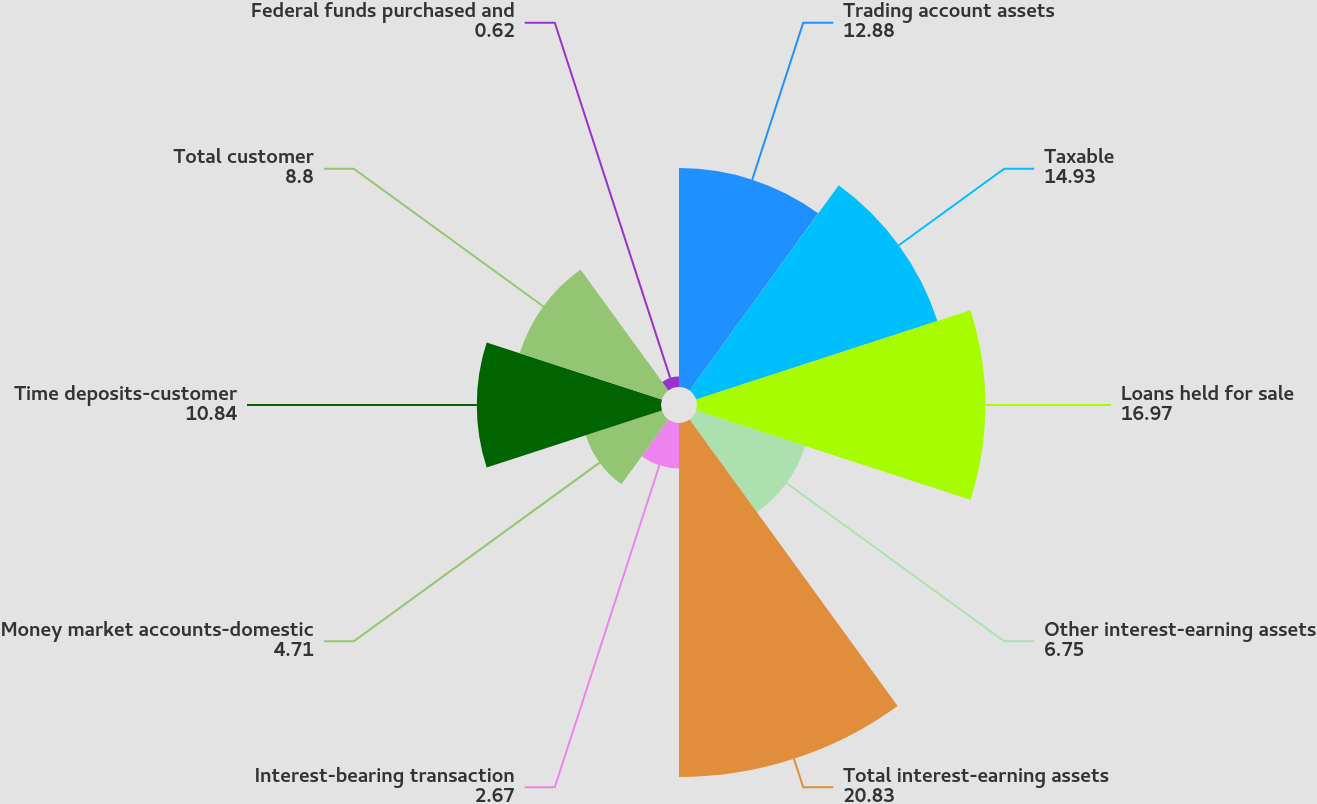<chart> <loc_0><loc_0><loc_500><loc_500><pie_chart><fcel>Trading account assets<fcel>Taxable<fcel>Loans held for sale<fcel>Other interest-earning assets<fcel>Total interest-earning assets<fcel>Interest-bearing transaction<fcel>Money market accounts-domestic<fcel>Time deposits-customer<fcel>Total customer<fcel>Federal funds purchased and<nl><fcel>12.88%<fcel>14.93%<fcel>16.97%<fcel>6.75%<fcel>20.83%<fcel>2.67%<fcel>4.71%<fcel>10.84%<fcel>8.8%<fcel>0.62%<nl></chart> 